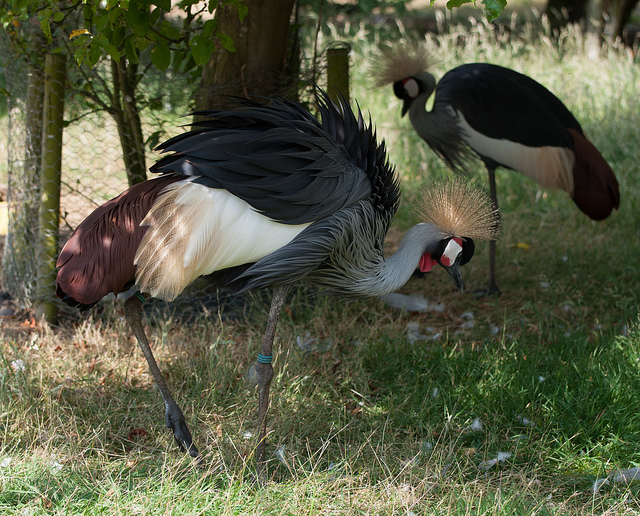<image>What type of birds are these? I don't know what type of birds these are. They could be peacocks, ostriches, cranes, turkeys, flamencos, or swans. What type of birds are these? I don't know what type of birds are these. They can be peacock, ostrich, black crowned crane, crane, turkeys, peacock, flamenco, wild, or swans. 